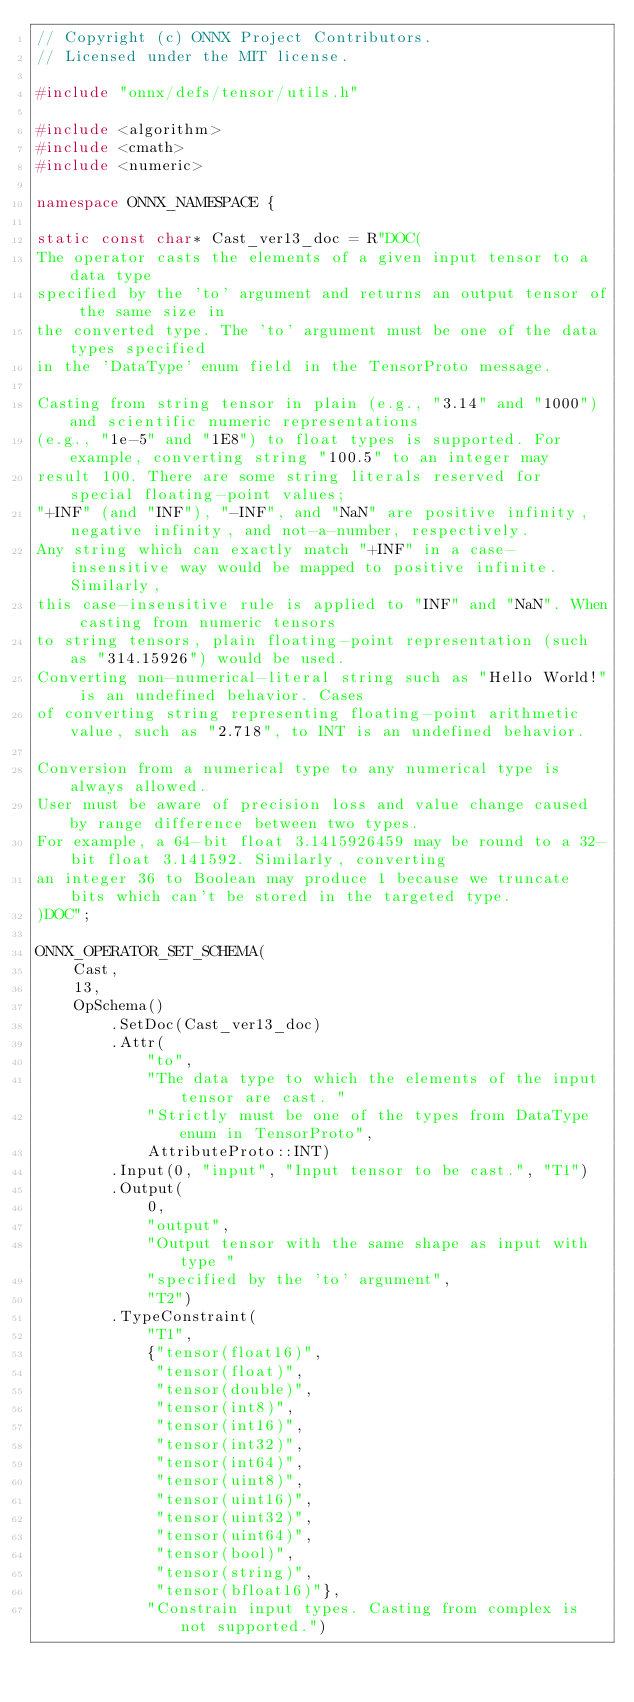Convert code to text. <code><loc_0><loc_0><loc_500><loc_500><_C++_>// Copyright (c) ONNX Project Contributors.
// Licensed under the MIT license.

#include "onnx/defs/tensor/utils.h"

#include <algorithm>
#include <cmath>
#include <numeric>

namespace ONNX_NAMESPACE {

static const char* Cast_ver13_doc = R"DOC(
The operator casts the elements of a given input tensor to a data type
specified by the 'to' argument and returns an output tensor of the same size in
the converted type. The 'to' argument must be one of the data types specified
in the 'DataType' enum field in the TensorProto message.

Casting from string tensor in plain (e.g., "3.14" and "1000") and scientific numeric representations
(e.g., "1e-5" and "1E8") to float types is supported. For example, converting string "100.5" to an integer may
result 100. There are some string literals reserved for special floating-point values;
"+INF" (and "INF"), "-INF", and "NaN" are positive infinity, negative infinity, and not-a-number, respectively.
Any string which can exactly match "+INF" in a case-insensitive way would be mapped to positive infinite. Similarly,
this case-insensitive rule is applied to "INF" and "NaN". When casting from numeric tensors
to string tensors, plain floating-point representation (such as "314.15926") would be used. 
Converting non-numerical-literal string such as "Hello World!" is an undefined behavior. Cases 
of converting string representing floating-point arithmetic value, such as "2.718", to INT is an undefined behavior.

Conversion from a numerical type to any numerical type is always allowed.
User must be aware of precision loss and value change caused by range difference between two types.
For example, a 64-bit float 3.1415926459 may be round to a 32-bit float 3.141592. Similarly, converting
an integer 36 to Boolean may produce 1 because we truncate bits which can't be stored in the targeted type.
)DOC";

ONNX_OPERATOR_SET_SCHEMA(
    Cast,
    13,
    OpSchema()
        .SetDoc(Cast_ver13_doc)
        .Attr(
            "to",
            "The data type to which the elements of the input tensor are cast. "
            "Strictly must be one of the types from DataType enum in TensorProto",
            AttributeProto::INT)
        .Input(0, "input", "Input tensor to be cast.", "T1")
        .Output(
            0,
            "output",
            "Output tensor with the same shape as input with type "
            "specified by the 'to' argument",
            "T2")
        .TypeConstraint(
            "T1",
            {"tensor(float16)",
             "tensor(float)",
             "tensor(double)",
             "tensor(int8)",
             "tensor(int16)",
             "tensor(int32)",
             "tensor(int64)",
             "tensor(uint8)",
             "tensor(uint16)",
             "tensor(uint32)",
             "tensor(uint64)",
             "tensor(bool)",
             "tensor(string)",
             "tensor(bfloat16)"},
            "Constrain input types. Casting from complex is not supported.")</code> 